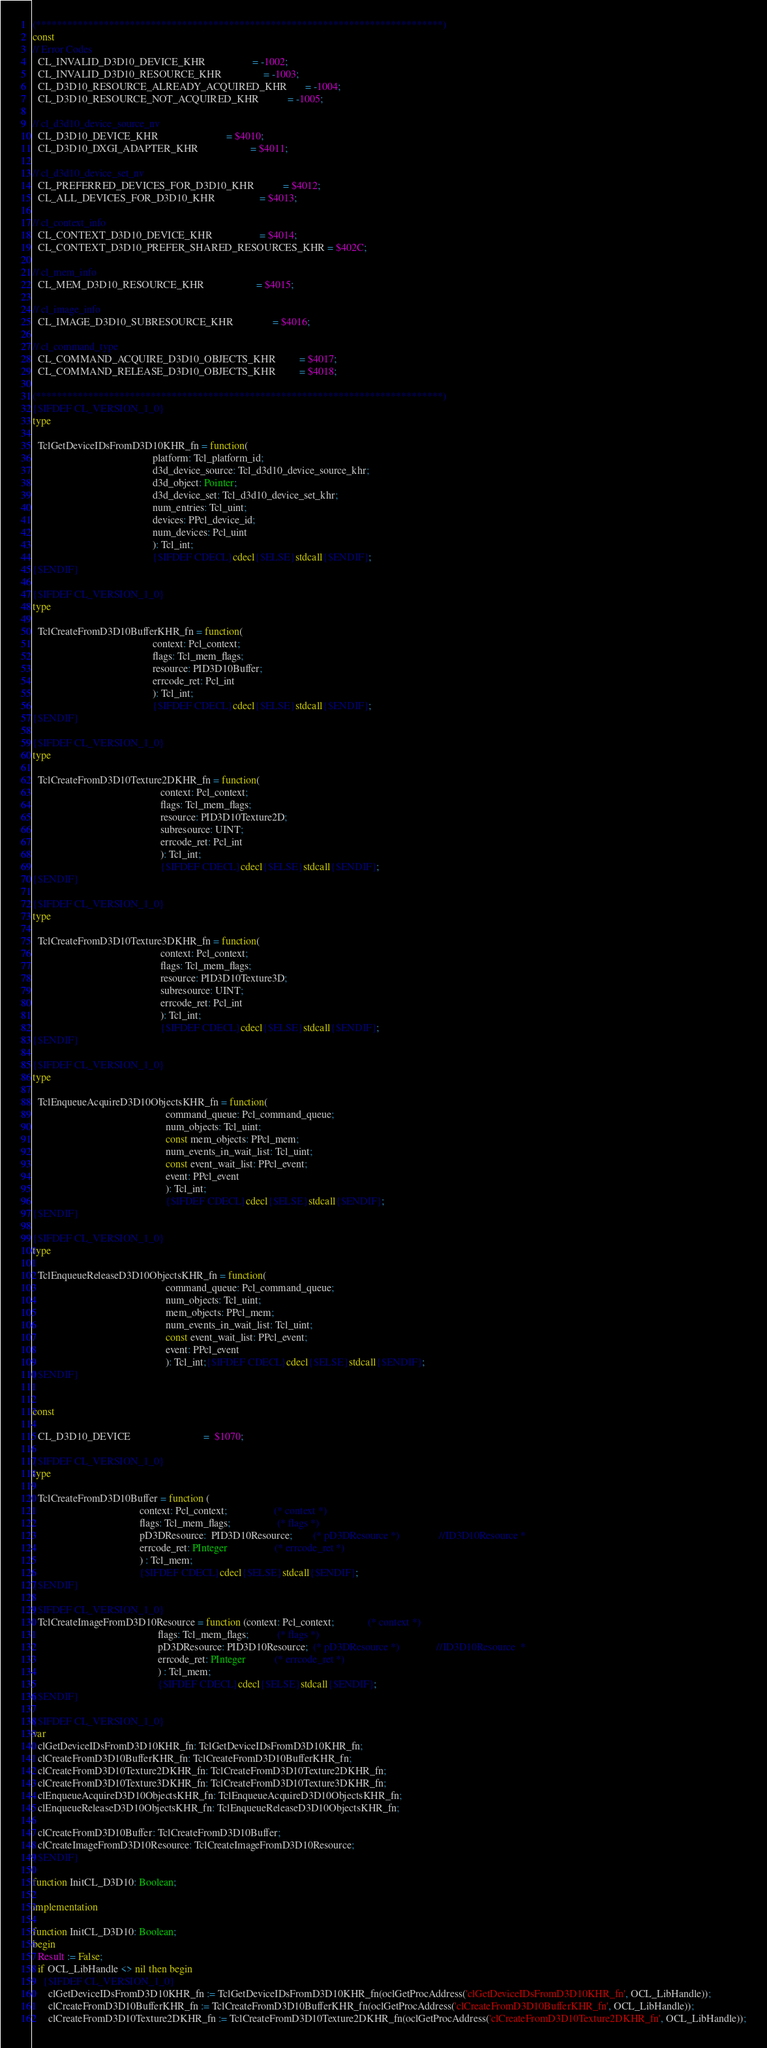<code> <loc_0><loc_0><loc_500><loc_500><_Pascal_>(******************************************************************************)
const
// Error Codes
  CL_INVALID_D3D10_DEVICE_KHR                  = -1002;
  CL_INVALID_D3D10_RESOURCE_KHR                = -1003;
  CL_D3D10_RESOURCE_ALREADY_ACQUIRED_KHR       = -1004;
  CL_D3D10_RESOURCE_NOT_ACQUIRED_KHR           = -1005;

// cl_d3d10_device_source_nv
  CL_D3D10_DEVICE_KHR                          = $4010;
  CL_D3D10_DXGI_ADAPTER_KHR                    = $4011;

// cl_d3d10_device_set_nv
  CL_PREFERRED_DEVICES_FOR_D3D10_KHR           = $4012;
  CL_ALL_DEVICES_FOR_D3D10_KHR                 = $4013;

// cl_context_info
  CL_CONTEXT_D3D10_DEVICE_KHR                  = $4014;
  CL_CONTEXT_D3D10_PREFER_SHARED_RESOURCES_KHR = $402C;

// cl_mem_info
  CL_MEM_D3D10_RESOURCE_KHR                    = $4015;

// cl_image_info
  CL_IMAGE_D3D10_SUBRESOURCE_KHR               = $4016;

// cl_command_type
  CL_COMMAND_ACQUIRE_D3D10_OBJECTS_KHR         = $4017;
  CL_COMMAND_RELEASE_D3D10_OBJECTS_KHR         = $4018;

(******************************************************************************)
{$IFDEF CL_VERSION_1_0}
type

  TclGetDeviceIDsFromD3D10KHR_fn = function(
                                              platform: Tcl_platform_id;
                                              d3d_device_source: Tcl_d3d10_device_source_khr;
                                              d3d_object: Pointer;
                                              d3d_device_set: Tcl_d3d10_device_set_khr;
                                              num_entries: Tcl_uint;
                                              devices: PPcl_device_id;
                                              num_devices: Pcl_uint
                                              ): Tcl_int;
                                              {$IFDEF CDECL}cdecl{$ELSE}stdcall{$ENDIF};
{$ENDIF}

{$IFDEF CL_VERSION_1_0}
type

  TclCreateFromD3D10BufferKHR_fn = function(
                                              context: Pcl_context;
                                              flags: Tcl_mem_flags;
                                              resource: PID3D10Buffer;
                                              errcode_ret: Pcl_int
                                              ): Tcl_int;
                                              {$IFDEF CDECL}cdecl{$ELSE}stdcall{$ENDIF};
{$ENDIF}

{$IFDEF CL_VERSION_1_0}
type

  TclCreateFromD3D10Texture2DKHR_fn = function(
                                                 context: Pcl_context;
                                                 flags: Tcl_mem_flags;
                                                 resource: PID3D10Texture2D;
                                                 subresource: UINT;
                                                 errcode_ret: Pcl_int
                                                 ): Tcl_int;
                                                 {$IFDEF CDECL}cdecl{$ELSE}stdcall{$ENDIF};
{$ENDIF}

{$IFDEF CL_VERSION_1_0}
type

  TclCreateFromD3D10Texture3DKHR_fn = function(
                                                 context: Pcl_context;
                                                 flags: Tcl_mem_flags;
                                                 resource: PID3D10Texture3D;
                                                 subresource: UINT;
                                                 errcode_ret: Pcl_int
                                                 ): Tcl_int;
                                                 {$IFDEF CDECL}cdecl{$ELSE}stdcall{$ENDIF};
{$ENDIF}

{$IFDEF CL_VERSION_1_0}
type

  TclEnqueueAcquireD3D10ObjectsKHR_fn = function(
                                                   command_queue: Pcl_command_queue;
                                                   num_objects: Tcl_uint;
                                                   const mem_objects: PPcl_mem;
                                                   num_events_in_wait_list: Tcl_uint;
                                                   const event_wait_list: PPcl_event;
                                                   event: PPcl_event
                                                   ): Tcl_int;
                                                   {$IFDEF CDECL}cdecl{$ELSE}stdcall{$ENDIF};
{$ENDIF}

{$IFDEF CL_VERSION_1_0}
type

  TclEnqueueReleaseD3D10ObjectsKHR_fn = function(
                                                   command_queue: Pcl_command_queue;
                                                   num_objects: Tcl_uint;
                                                   mem_objects: PPcl_mem;
                                                   num_events_in_wait_list: Tcl_uint;
                                                   const event_wait_list: PPcl_event;
                                                   event: PPcl_event
                                                   ): Tcl_int;{$IFDEF CDECL}cdecl{$ELSE}stdcall{$ENDIF};
{$ENDIF}


const

  CL_D3D10_DEVICE                            =  $1070;

{$IFDEF CL_VERSION_1_0}
type

  TclCreateFromD3D10Buffer = function (
                                         context: Pcl_context;                  (* context *)
                                         flags: Tcl_mem_flags;                  (* flags *)
                                         pD3DResource:  PID3D10Resource;        (* pD3DResource *)               //ID3D10Resource *
                                         errcode_ret: PInteger                  (* errcode_ret *)
                                         ) : Tcl_mem;
                                         {$IFDEF CDECL}cdecl{$ELSE}stdcall{$ENDIF};
{$ENDIF}

{$IFDEF CL_VERSION_1_0}
  TclCreateImageFromD3D10Resource = function (context: Pcl_context;             (* context *)
                                                flags: Tcl_mem_flags;           (* flags *)
                                                pD3DResource: PID3D10Resource;  (* pD3DResource *)              //ID3D10Resource  *
                                                errcode_ret: PInteger           (* errcode_ret *)
                                                ) : Tcl_mem;
                                                {$IFDEF CDECL}cdecl{$ELSE}stdcall{$ENDIF};
{$ENDIF}

{$IFDEF CL_VERSION_1_0}
var
  clGetDeviceIDsFromD3D10KHR_fn: TclGetDeviceIDsFromD3D10KHR_fn;
  clCreateFromD3D10BufferKHR_fn: TclCreateFromD3D10BufferKHR_fn;
  clCreateFromD3D10Texture2DKHR_fn: TclCreateFromD3D10Texture2DKHR_fn;
  clCreateFromD3D10Texture3DKHR_fn: TclCreateFromD3D10Texture3DKHR_fn;
  clEnqueueAcquireD3D10ObjectsKHR_fn: TclEnqueueAcquireD3D10ObjectsKHR_fn;
  clEnqueueReleaseD3D10ObjectsKHR_fn: TclEnqueueReleaseD3D10ObjectsKHR_fn;

  clCreateFromD3D10Buffer: TclCreateFromD3D10Buffer;
  clCreateImageFromD3D10Resource: TclCreateImageFromD3D10Resource;
{$ENDIF}

function InitCL_D3D10: Boolean;

implementation

function InitCL_D3D10: Boolean;
begin
  Result := False;
  if OCL_LibHandle <> nil then begin
    {$IFDEF CL_VERSION_1_0}
      clGetDeviceIDsFromD3D10KHR_fn := TclGetDeviceIDsFromD3D10KHR_fn(oclGetProcAddress('clGetDeviceIDsFromD3D10KHR_fn', OCL_LibHandle));
      clCreateFromD3D10BufferKHR_fn := TclCreateFromD3D10BufferKHR_fn(oclGetProcAddress('clCreateFromD3D10BufferKHR_fn', OCL_LibHandle));
      clCreateFromD3D10Texture2DKHR_fn := TclCreateFromD3D10Texture2DKHR_fn(oclGetProcAddress('clCreateFromD3D10Texture2DKHR_fn', OCL_LibHandle));</code> 